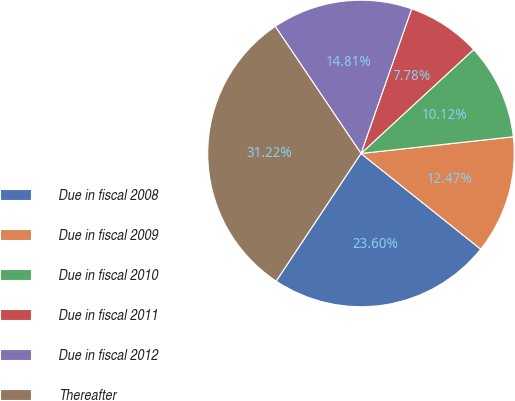Convert chart to OTSL. <chart><loc_0><loc_0><loc_500><loc_500><pie_chart><fcel>Due in fiscal 2008<fcel>Due in fiscal 2009<fcel>Due in fiscal 2010<fcel>Due in fiscal 2011<fcel>Due in fiscal 2012<fcel>Thereafter<nl><fcel>23.6%<fcel>12.47%<fcel>10.12%<fcel>7.78%<fcel>14.81%<fcel>31.22%<nl></chart> 